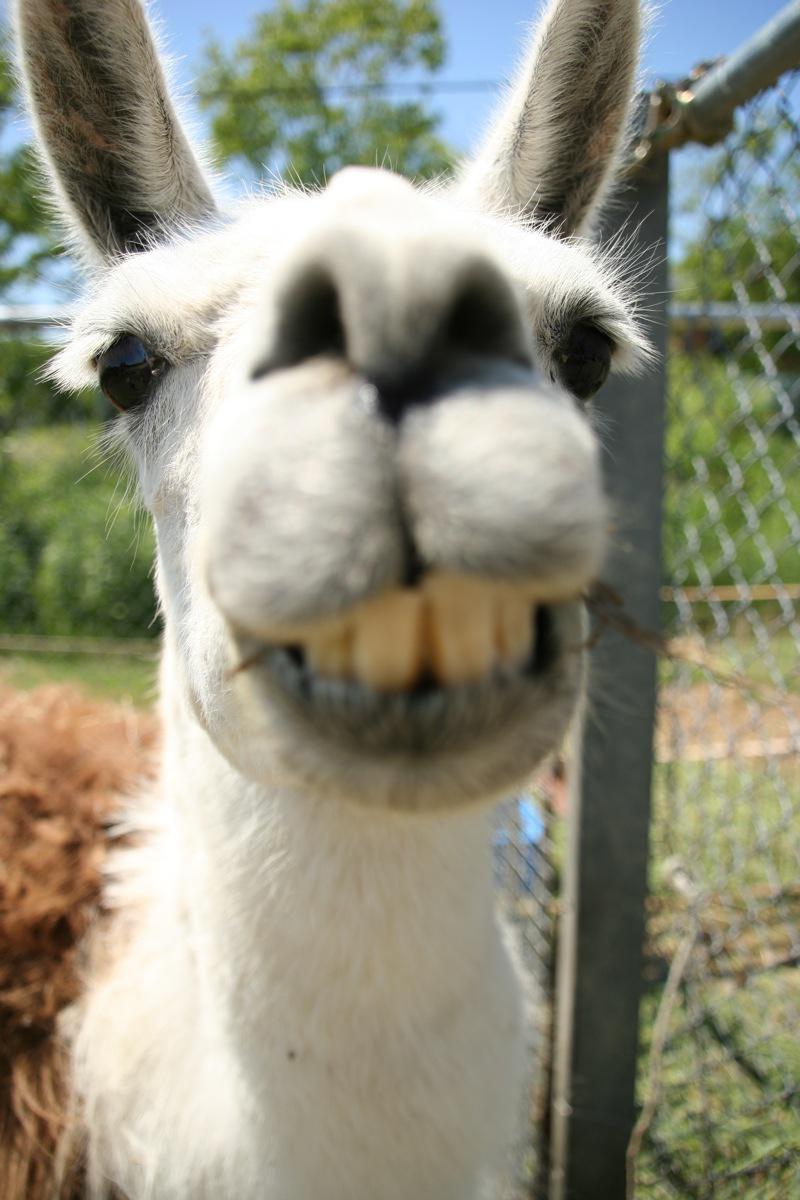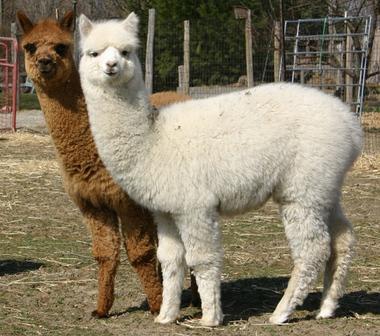The first image is the image on the left, the second image is the image on the right. Examine the images to the left and right. Is the description "In one of the images there is a brown llama standing behind a paler llama." accurate? Answer yes or no. Yes. The first image is the image on the left, the second image is the image on the right. For the images shown, is this caption "One image contains two face-forward llamas with shaggy necks, and the other image includes at least one llama with a sheared neck and round head." true? Answer yes or no. No. 